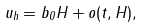Convert formula to latex. <formula><loc_0><loc_0><loc_500><loc_500>u _ { h } = b _ { 0 } H + o ( t , H ) ,</formula> 